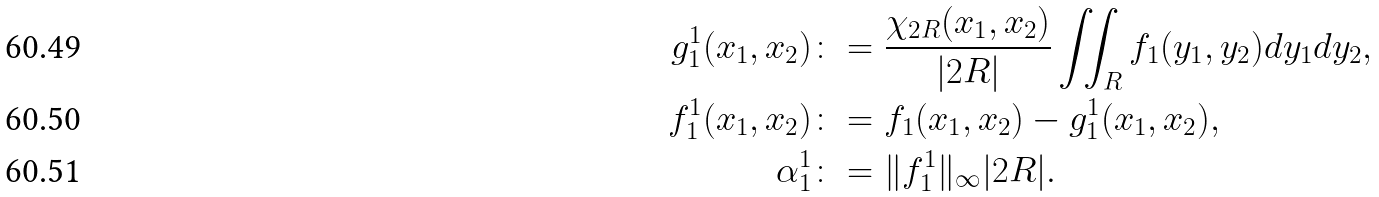Convert formula to latex. <formula><loc_0><loc_0><loc_500><loc_500>g _ { 1 } ^ { 1 } ( x _ { 1 } , x _ { 2 } ) & \colon = \frac { \chi _ { 2 R } ( x _ { 1 } , x _ { 2 } ) } { | 2 R | } \iint _ { R } f _ { 1 } ( y _ { 1 } , y _ { 2 } ) d y _ { 1 } d y _ { 2 } , \\ f _ { 1 } ^ { 1 } ( x _ { 1 } , x _ { 2 } ) & \colon = f _ { 1 } ( x _ { 1 } , x _ { 2 } ) - g _ { 1 } ^ { 1 } ( x _ { 1 } , x _ { 2 } ) , \\ \alpha _ { 1 } ^ { 1 } & \colon = \| f _ { 1 } ^ { 1 } \| _ { \infty } | 2 R | .</formula> 